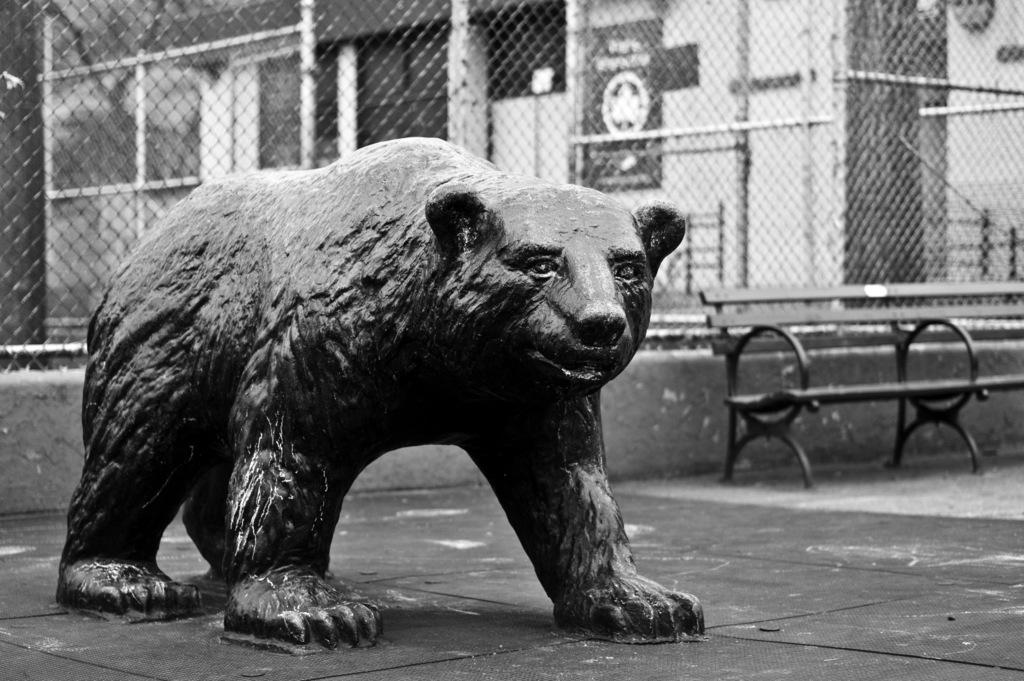What is the color scheme of the image? The image is in black and white. What is the main subject of the image? There is a statue of a bear in the image. What is located behind the statue? There is fencing behind the statue. What type of seating is available in the image? A bench is present in the image. What can be seen in the background of the image? There is a building in the background. How does the bean affect the shock in the image? There is no bean or shock present in the image; it features a statue of a bear, fencing, a bench, and a building in the background. 